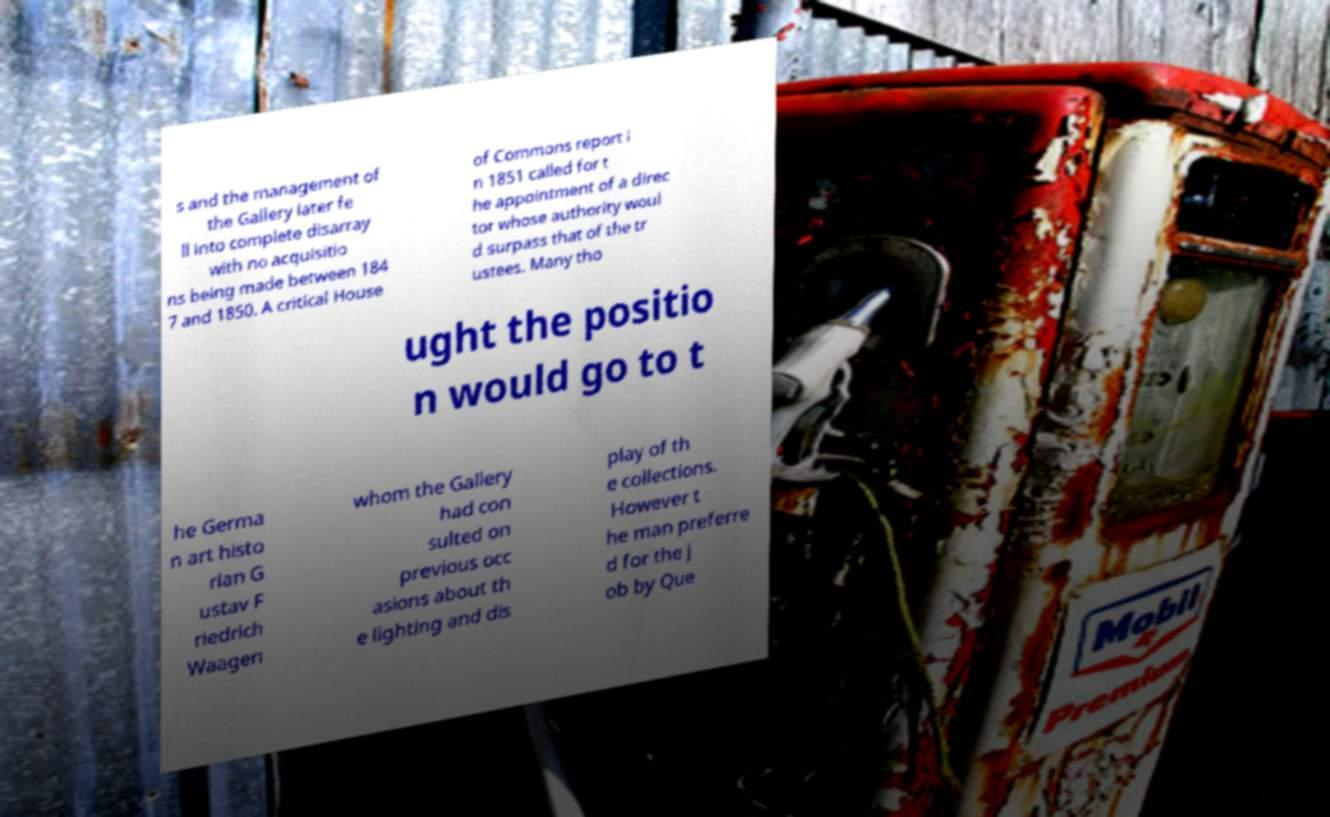Could you assist in decoding the text presented in this image and type it out clearly? s and the management of the Gallery later fe ll into complete disarray with no acquisitio ns being made between 184 7 and 1850. A critical House of Commons report i n 1851 called for t he appointment of a direc tor whose authority woul d surpass that of the tr ustees. Many tho ught the positio n would go to t he Germa n art histo rian G ustav F riedrich Waagen whom the Gallery had con sulted on previous occ asions about th e lighting and dis play of th e collections. However t he man preferre d for the j ob by Que 